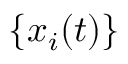Convert formula to latex. <formula><loc_0><loc_0><loc_500><loc_500>\{ x _ { i } ( t ) \}</formula> 